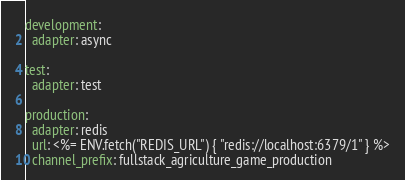Convert code to text. <code><loc_0><loc_0><loc_500><loc_500><_YAML_>development:
  adapter: async

test:
  adapter: test

production:
  adapter: redis
  url: <%= ENV.fetch("REDIS_URL") { "redis://localhost:6379/1" } %>
  channel_prefix: fullstack_agriculture_game_production
</code> 